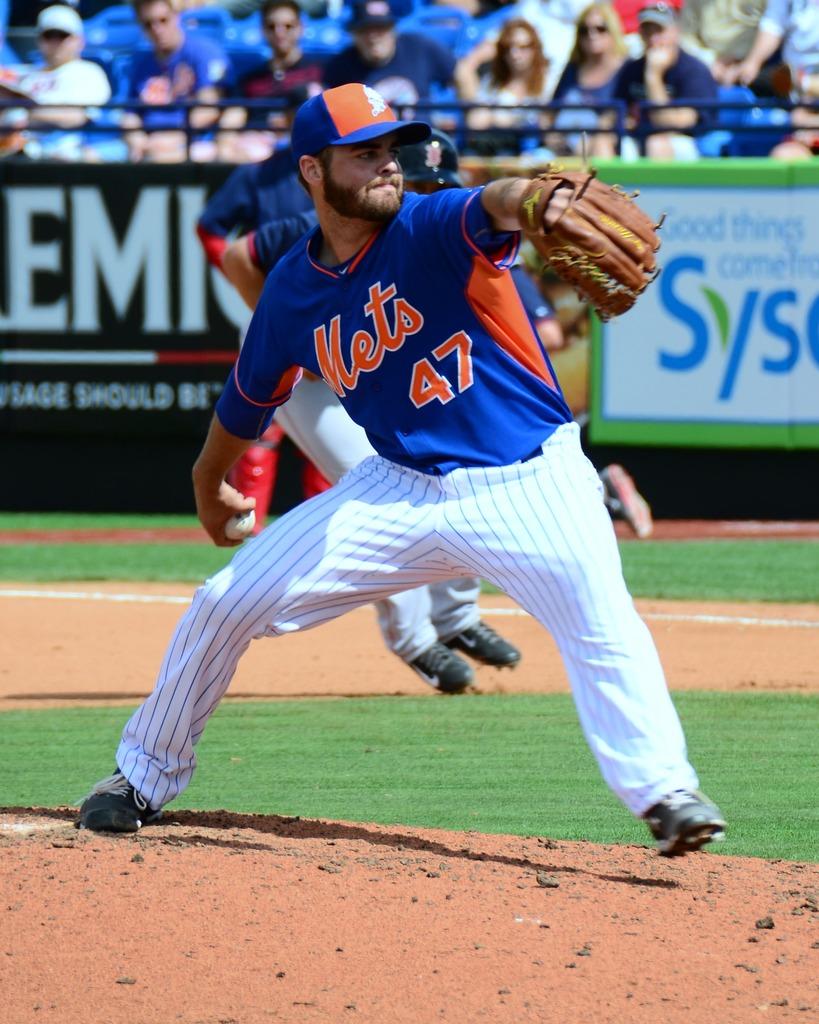What is the name of the team?
Provide a short and direct response. Mets. 